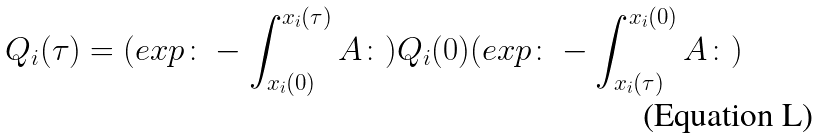<formula> <loc_0><loc_0><loc_500><loc_500>Q _ { i } ( \tau ) = ( e x p \colon - \int _ { x _ { i } ( 0 ) } ^ { x _ { i } ( \tau ) } A \colon ) Q _ { i } ( 0 ) ( e x p \colon - \int _ { x _ { i } ( \tau ) } ^ { x _ { i } ( 0 ) } A \colon )</formula> 